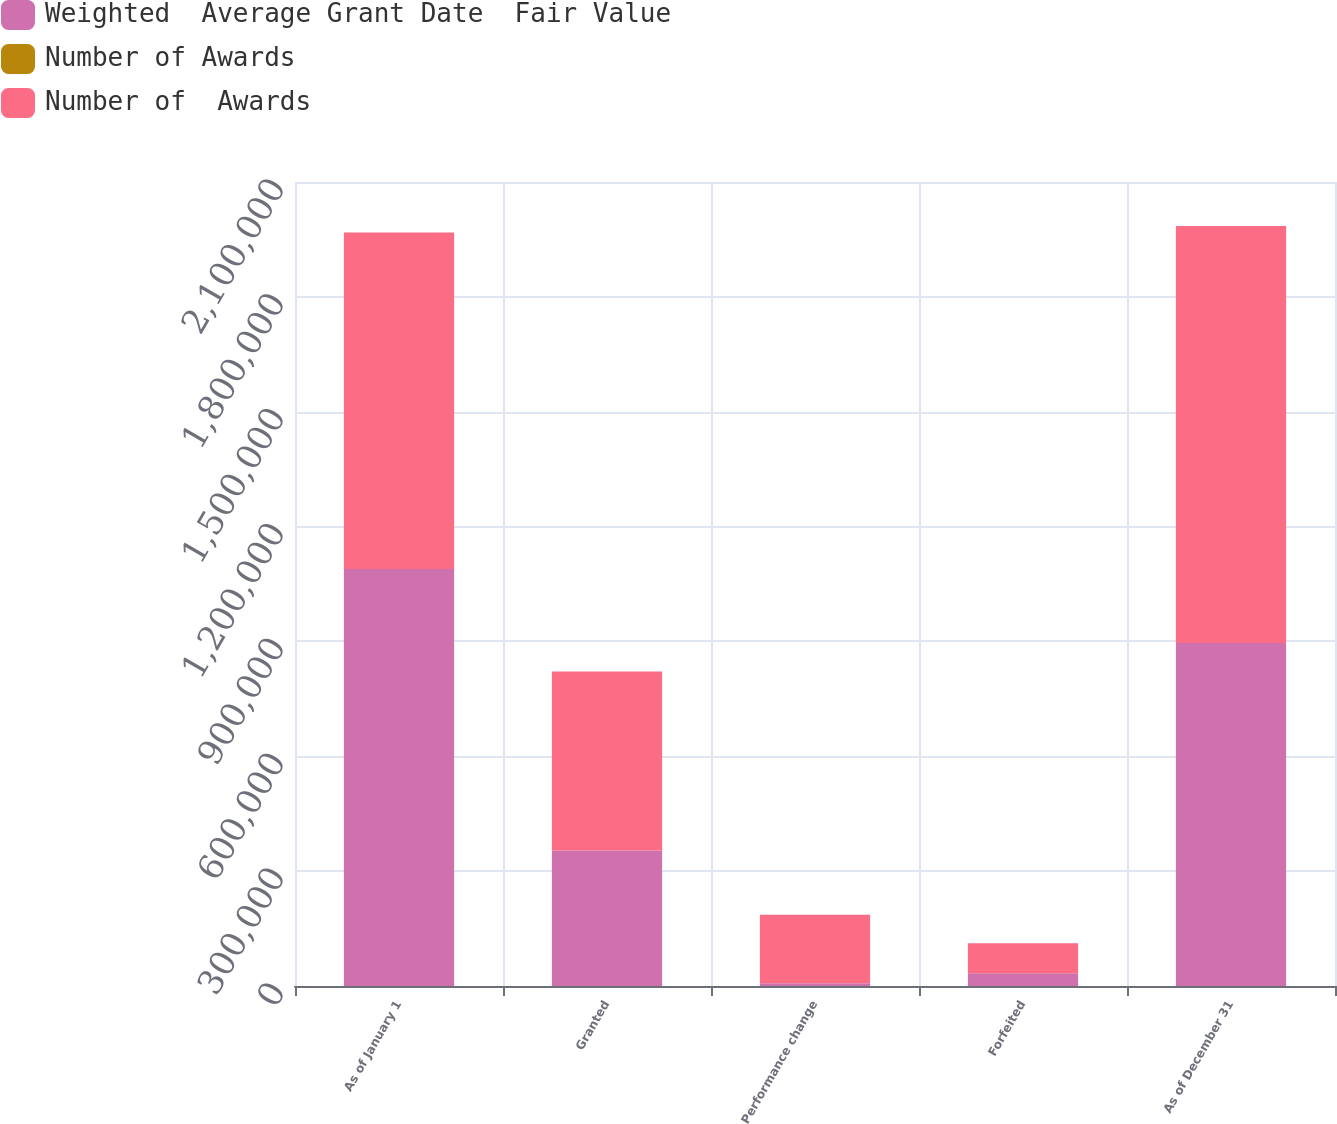<chart> <loc_0><loc_0><loc_500><loc_500><stacked_bar_chart><ecel><fcel>As of January 1<fcel>Granted<fcel>Performance change<fcel>Forfeited<fcel>As of December 31<nl><fcel>Weighted  Average Grant Date  Fair Value<fcel>1.08908e+06<fcel>353734<fcel>6949<fcel>33151<fcel>895635<nl><fcel>Number of Awards<fcel>79.27<fcel>96.87<fcel>77.01<fcel>91.34<fcel>88.12<nl><fcel>Number of  Awards<fcel>878872<fcel>467531<fcel>178838<fcel>78481<fcel>1.08908e+06<nl></chart> 